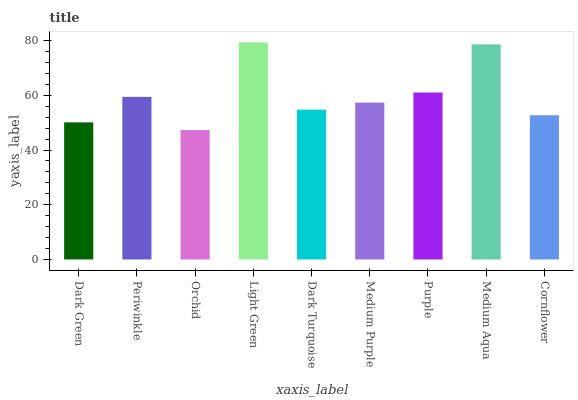Is Orchid the minimum?
Answer yes or no. Yes. Is Light Green the maximum?
Answer yes or no. Yes. Is Periwinkle the minimum?
Answer yes or no. No. Is Periwinkle the maximum?
Answer yes or no. No. Is Periwinkle greater than Dark Green?
Answer yes or no. Yes. Is Dark Green less than Periwinkle?
Answer yes or no. Yes. Is Dark Green greater than Periwinkle?
Answer yes or no. No. Is Periwinkle less than Dark Green?
Answer yes or no. No. Is Medium Purple the high median?
Answer yes or no. Yes. Is Medium Purple the low median?
Answer yes or no. Yes. Is Orchid the high median?
Answer yes or no. No. Is Cornflower the low median?
Answer yes or no. No. 